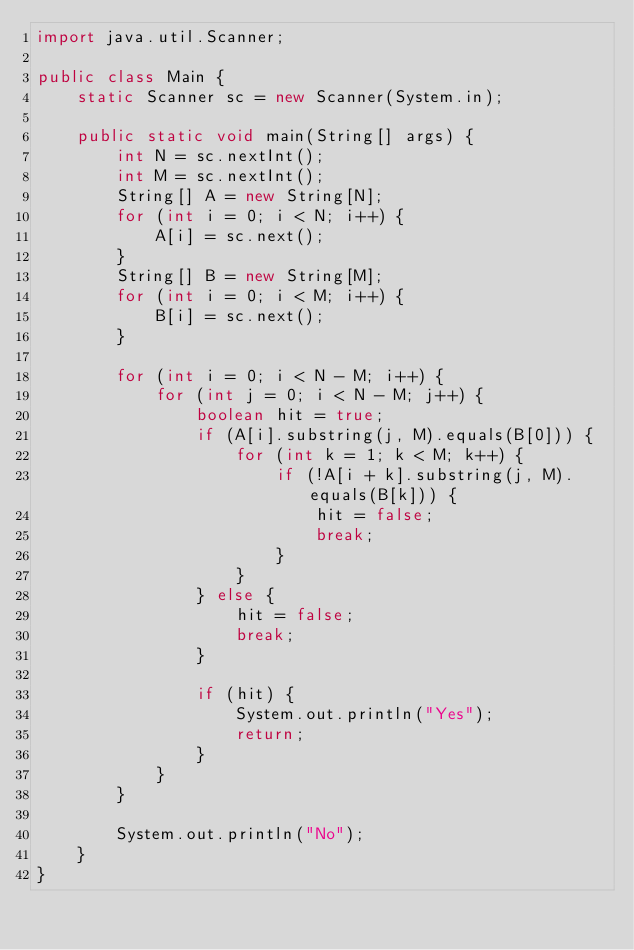Convert code to text. <code><loc_0><loc_0><loc_500><loc_500><_Java_>import java.util.Scanner;

public class Main {
	static Scanner sc = new Scanner(System.in);

	public static void main(String[] args) {
		int N = sc.nextInt();
		int M = sc.nextInt();
		String[] A = new String[N];
		for (int i = 0; i < N; i++) {
			A[i] = sc.next();
		}
		String[] B = new String[M];
		for (int i = 0; i < M; i++) {
			B[i] = sc.next();
		}
		
		for (int i = 0; i < N - M; i++) {
			for (int j = 0; i < N - M; j++) {
				boolean hit = true;
				if (A[i].substring(j, M).equals(B[0])) {
					for (int k = 1; k < M; k++) {
						if (!A[i + k].substring(j, M).equals(B[k])) {
							hit = false;
							break;
						}
					}
				} else {
					hit = false;
					break;
				}
				
				if (hit) {
					System.out.println("Yes");
					return;
				}
			}
		}
		
		System.out.println("No");
	}
}
</code> 